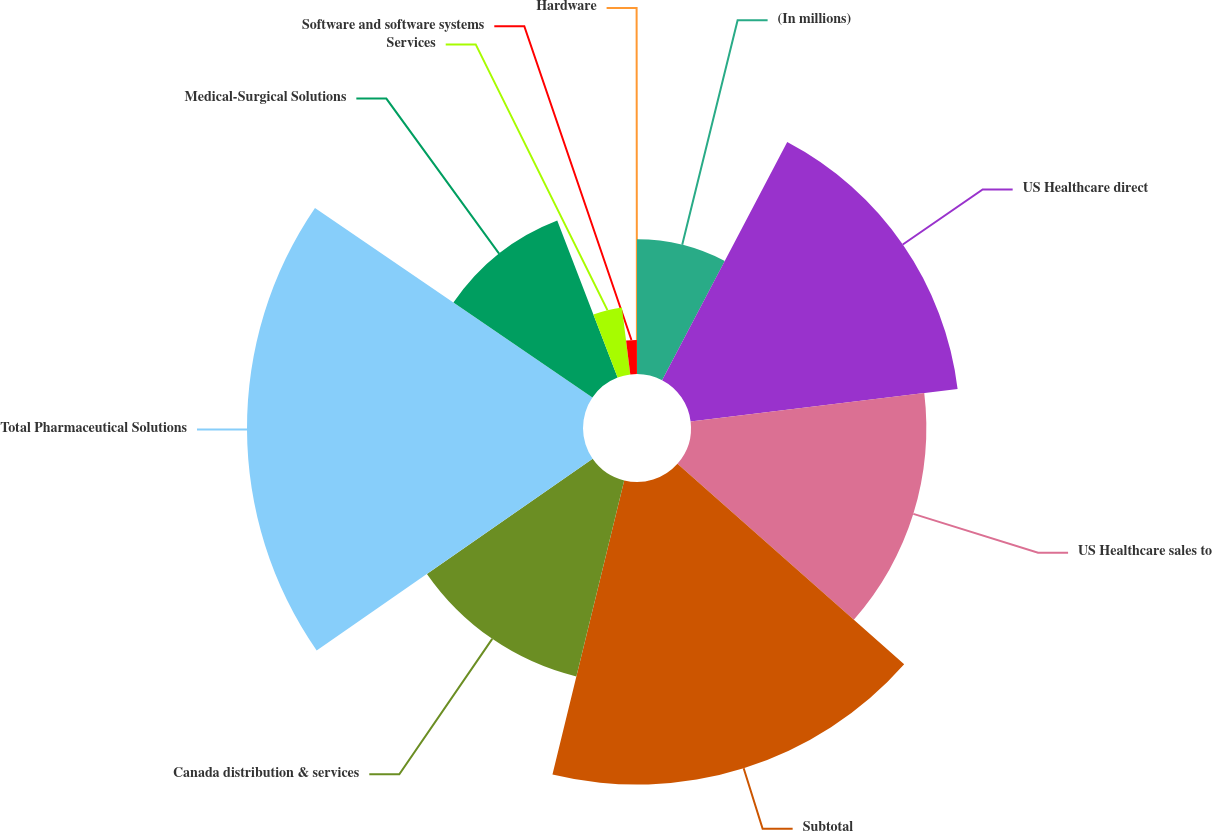<chart> <loc_0><loc_0><loc_500><loc_500><pie_chart><fcel>(In millions)<fcel>US Healthcare direct<fcel>US Healthcare sales to<fcel>Subtotal<fcel>Canada distribution & services<fcel>Total Pharmaceutical Solutions<fcel>Medical-Surgical Solutions<fcel>Services<fcel>Software and software systems<fcel>Hardware<nl><fcel>7.7%<fcel>15.37%<fcel>13.45%<fcel>17.29%<fcel>11.53%<fcel>19.2%<fcel>9.62%<fcel>3.86%<fcel>1.95%<fcel>0.03%<nl></chart> 